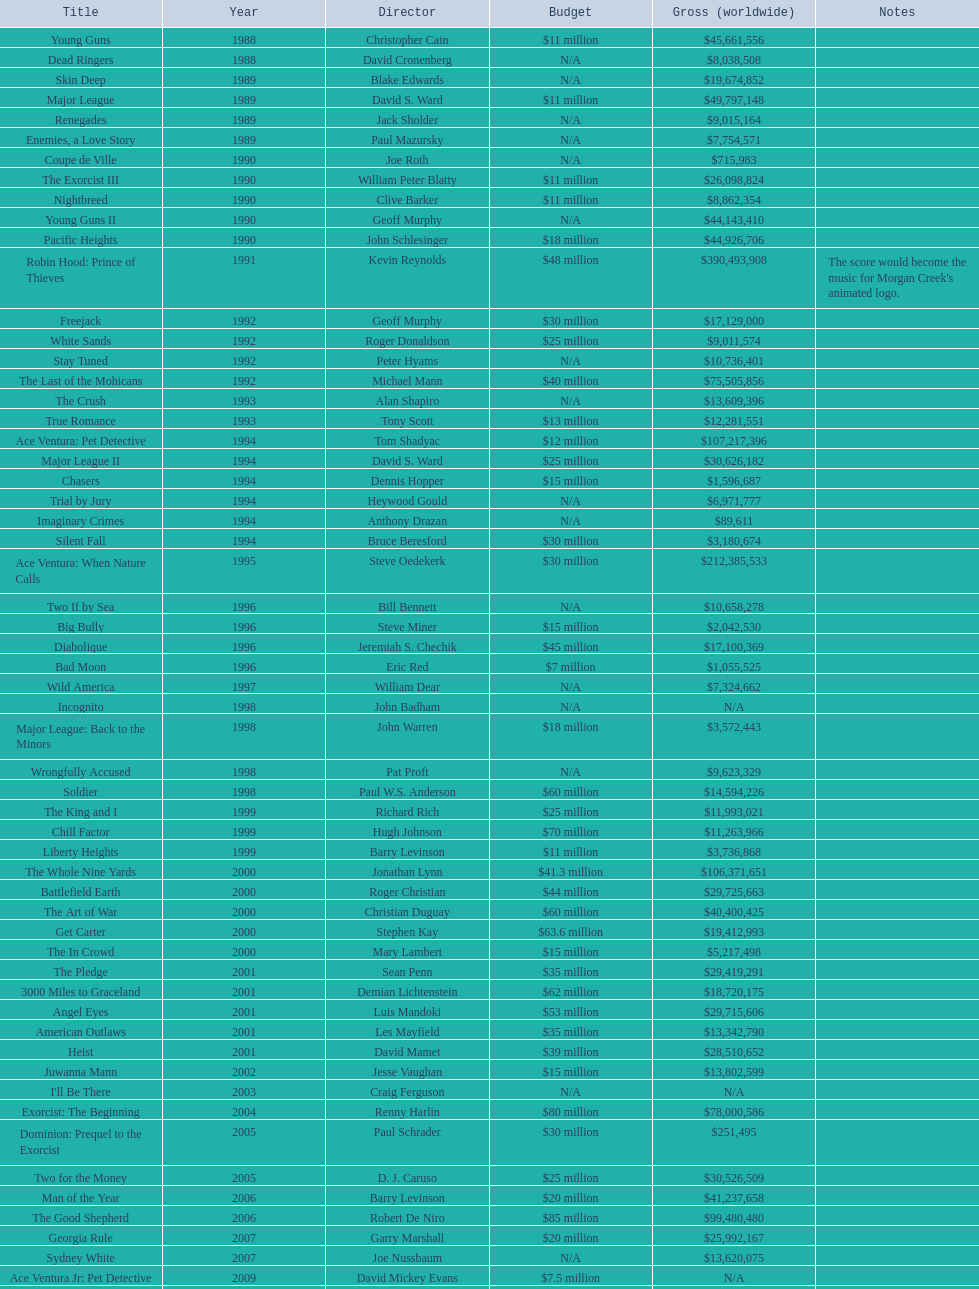Did true romance make more or less money than diabolique? Less. 